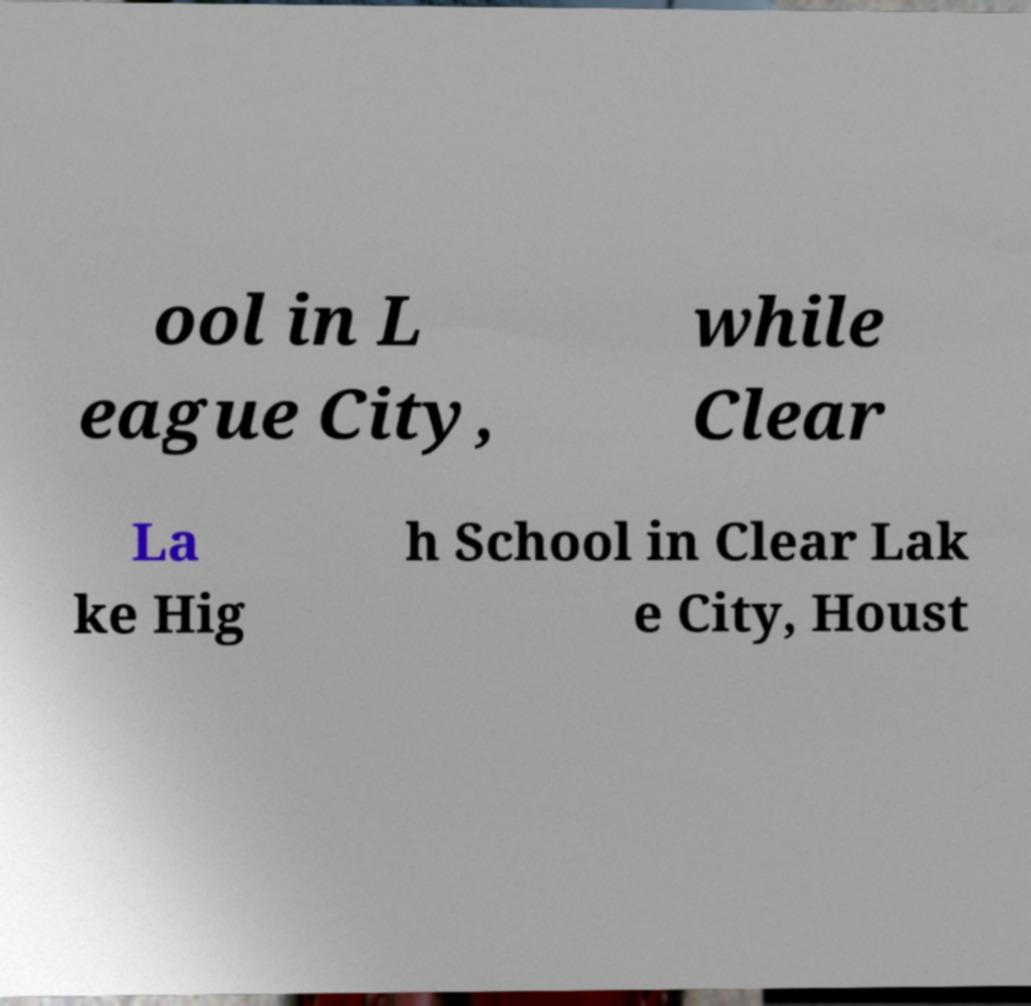For documentation purposes, I need the text within this image transcribed. Could you provide that? ool in L eague City, while Clear La ke Hig h School in Clear Lak e City, Houst 